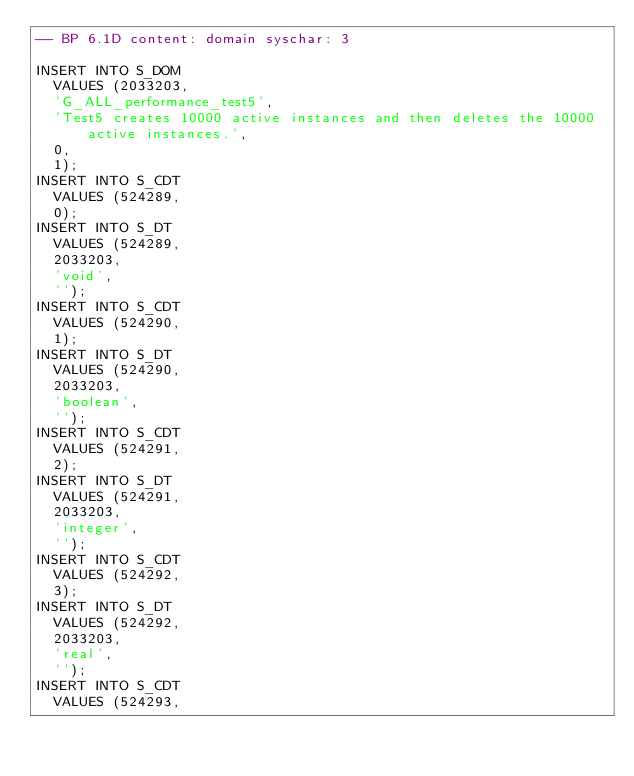<code> <loc_0><loc_0><loc_500><loc_500><_SQL_>-- BP 6.1D content: domain syschar: 3

INSERT INTO S_DOM
	VALUES (2033203,
	'G_ALL_performance_test5',
	'Test5 creates 10000 active instances and then deletes the 10000 active instances.',
	0,
	1);
INSERT INTO S_CDT
	VALUES (524289,
	0);
INSERT INTO S_DT
	VALUES (524289,
	2033203,
	'void',
	'');
INSERT INTO S_CDT
	VALUES (524290,
	1);
INSERT INTO S_DT
	VALUES (524290,
	2033203,
	'boolean',
	'');
INSERT INTO S_CDT
	VALUES (524291,
	2);
INSERT INTO S_DT
	VALUES (524291,
	2033203,
	'integer',
	'');
INSERT INTO S_CDT
	VALUES (524292,
	3);
INSERT INTO S_DT
	VALUES (524292,
	2033203,
	'real',
	'');
INSERT INTO S_CDT
	VALUES (524293,</code> 